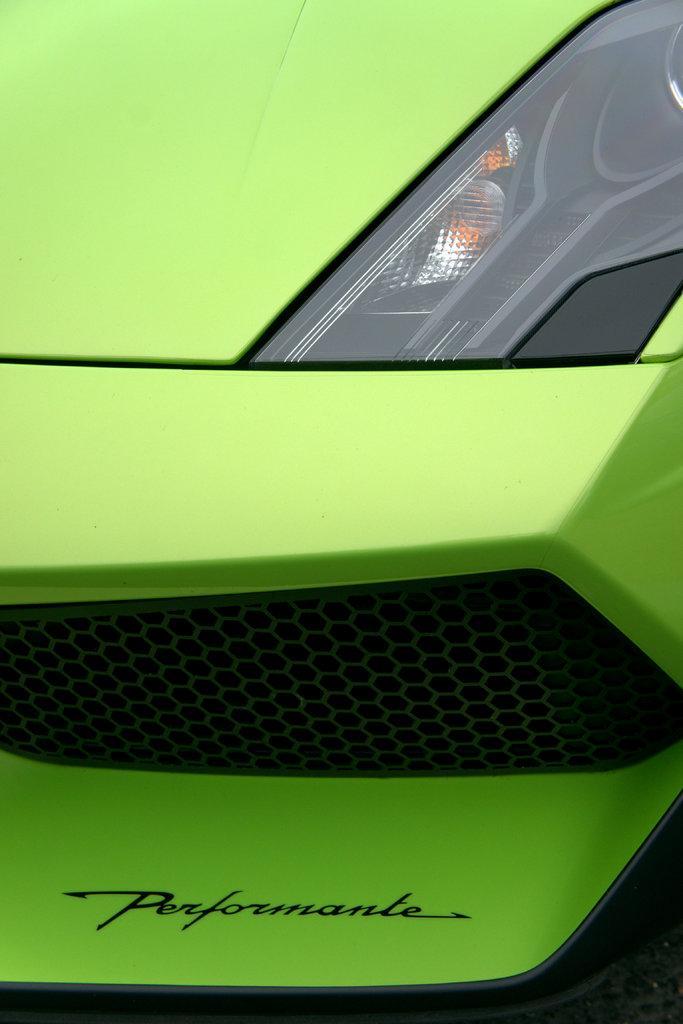Describe this image in one or two sentences. In this picture we can see green color vehicle. 